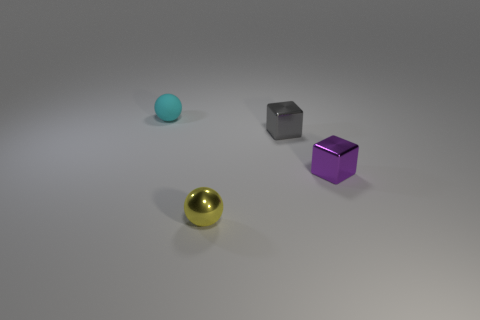Add 3 tiny purple matte cylinders. How many objects exist? 7 Add 4 yellow spheres. How many yellow spheres exist? 5 Subtract 1 gray blocks. How many objects are left? 3 Subtract all tiny yellow rubber cubes. Subtract all small purple shiny things. How many objects are left? 3 Add 3 tiny cyan objects. How many tiny cyan objects are left? 4 